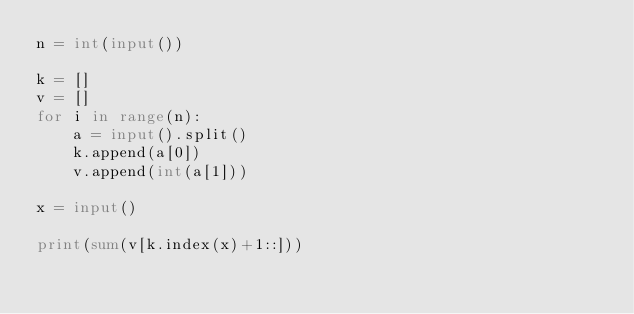<code> <loc_0><loc_0><loc_500><loc_500><_Python_>n = int(input())

k = []
v = []
for i in range(n):
    a = input().split()
    k.append(a[0])
    v.append(int(a[1]))

x = input()

print(sum(v[k.index(x)+1::]))</code> 